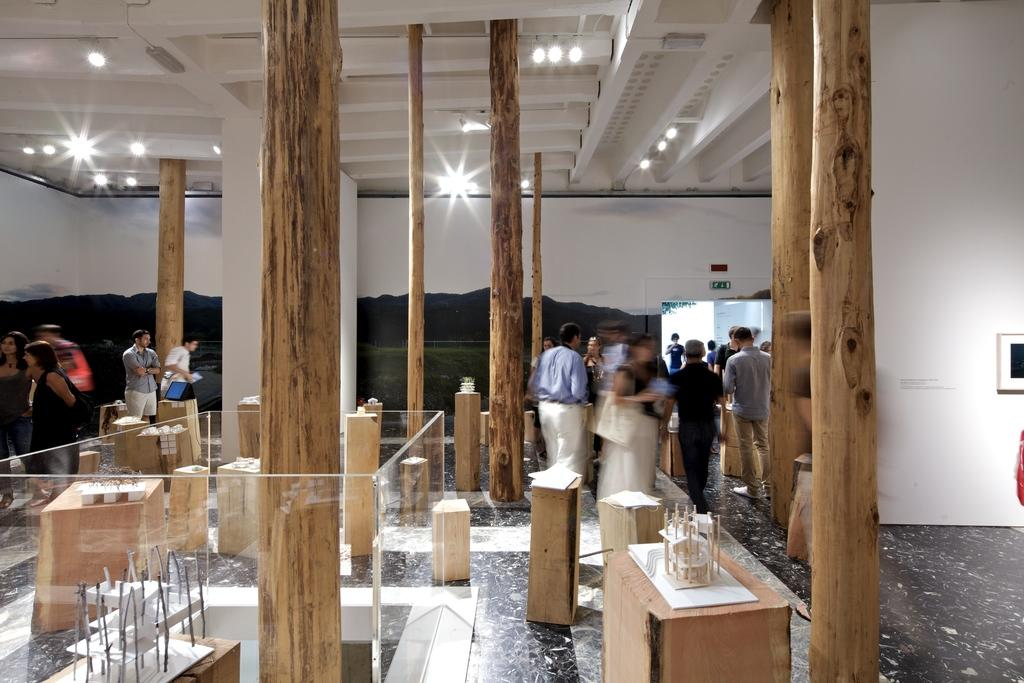Where are the people located in the image? There are people on both the right and left sides of the image. What type of material is visible in the image? The image appears to contain plywood stock. What type of book is the porter reading on vacation in the image? There is no porter or book present in the image, nor is there any indication of a vacation. 